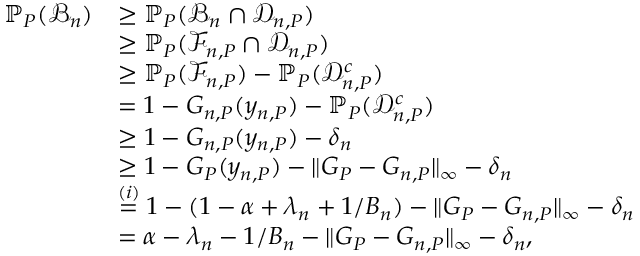Convert formula to latex. <formula><loc_0><loc_0><loc_500><loc_500>\begin{array} { r l } { \mathbb { P } _ { P } ( \mathcal { B } _ { n } ) } & { \geq \mathbb { P } _ { P } ( \mathcal { B } _ { n } \cap \mathcal { D } _ { n , P } ) } \\ & { \geq \mathbb { P } _ { P } ( \mathcal { F } _ { n , P } \cap \mathcal { D } _ { n , P } ) } \\ & { \geq \mathbb { P } _ { P } ( \mathcal { F } _ { n , P } ) - \mathbb { P } _ { P } ( \mathcal { D } _ { n , P } ^ { c } ) } \\ & { = 1 - G _ { n , P } ( y _ { n , P } ) - \mathbb { P } _ { P } ( \mathcal { D } _ { n , P } ^ { c } ) } \\ & { \geq 1 - G _ { n , P } ( y _ { n , P } ) - \delta _ { n } } \\ & { \geq 1 - G _ { P } ( y _ { n , P } ) - \| G _ { P } - G _ { n , P } \| _ { \infty } - \delta _ { n } } \\ & { \stackrel { ( i ) } { = } 1 - ( 1 - \alpha + \lambda _ { n } + 1 / B _ { n } ) - \| G _ { P } - G _ { n , P } \| _ { \infty } - \delta _ { n } } \\ & { = \alpha - \lambda _ { n } - 1 / B _ { n } - \| G _ { P } - G _ { n , P } \| _ { \infty } - \delta _ { n } , } \end{array}</formula> 